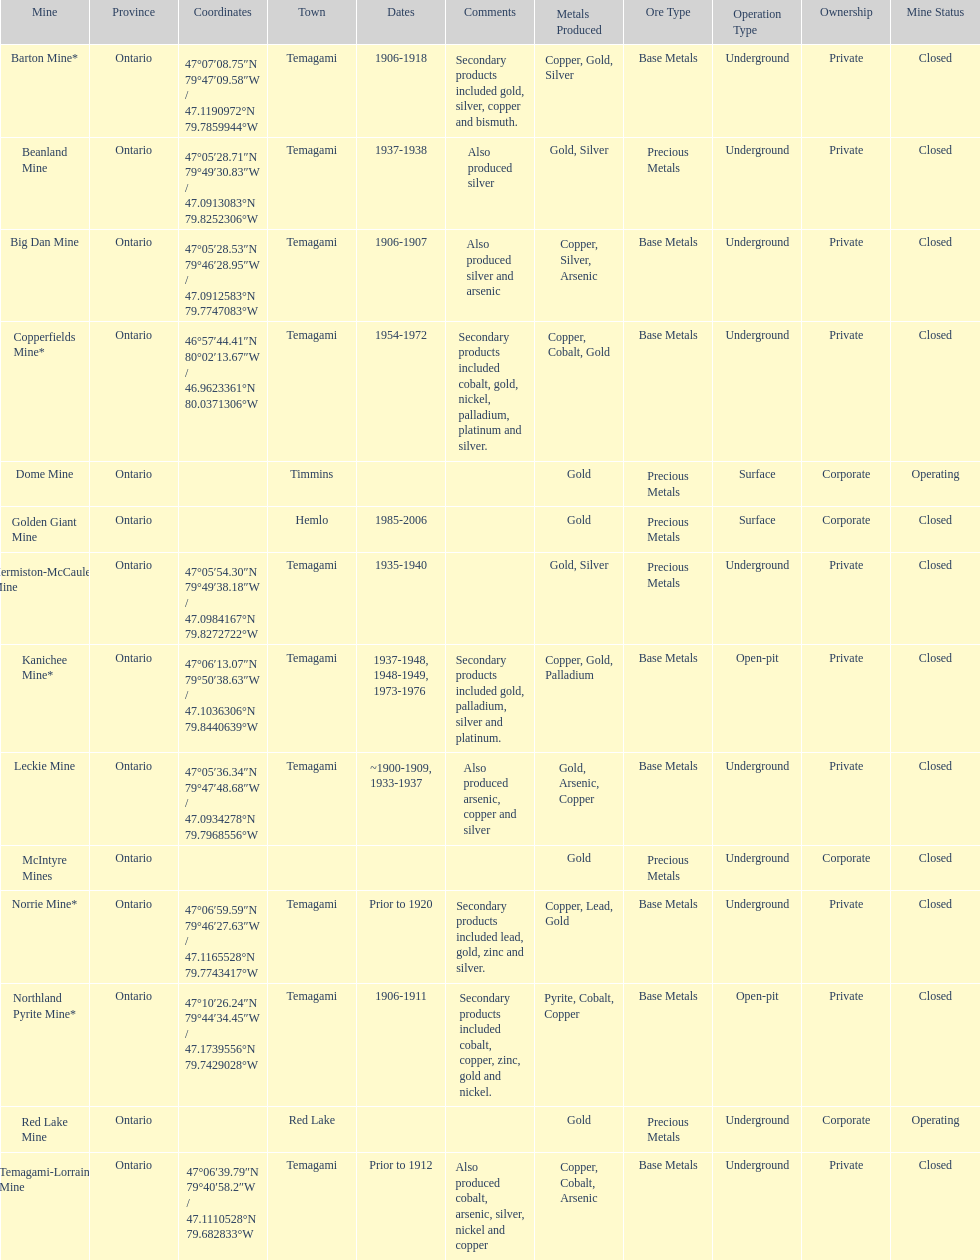Name a gold mine that was open at least 10 years. Barton Mine. 